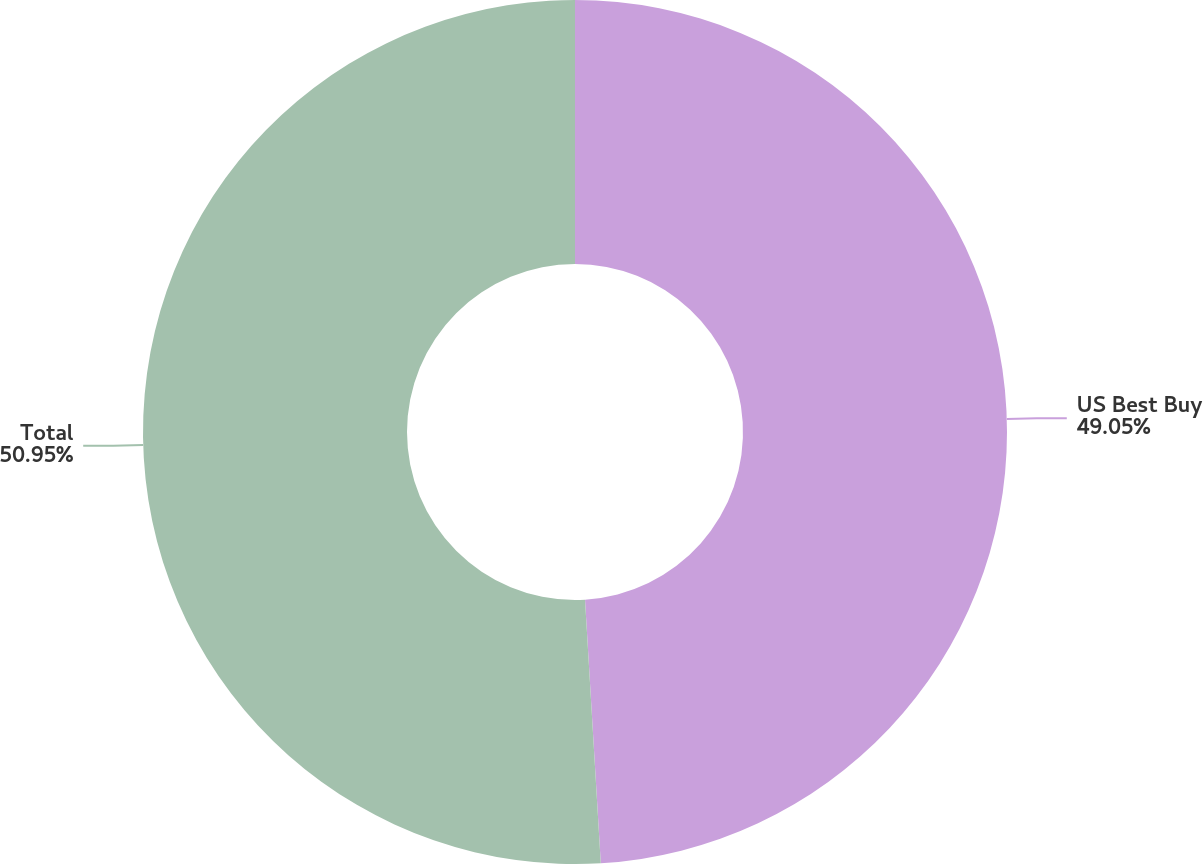Convert chart. <chart><loc_0><loc_0><loc_500><loc_500><pie_chart><fcel>US Best Buy<fcel>Total<nl><fcel>49.05%<fcel>50.95%<nl></chart> 